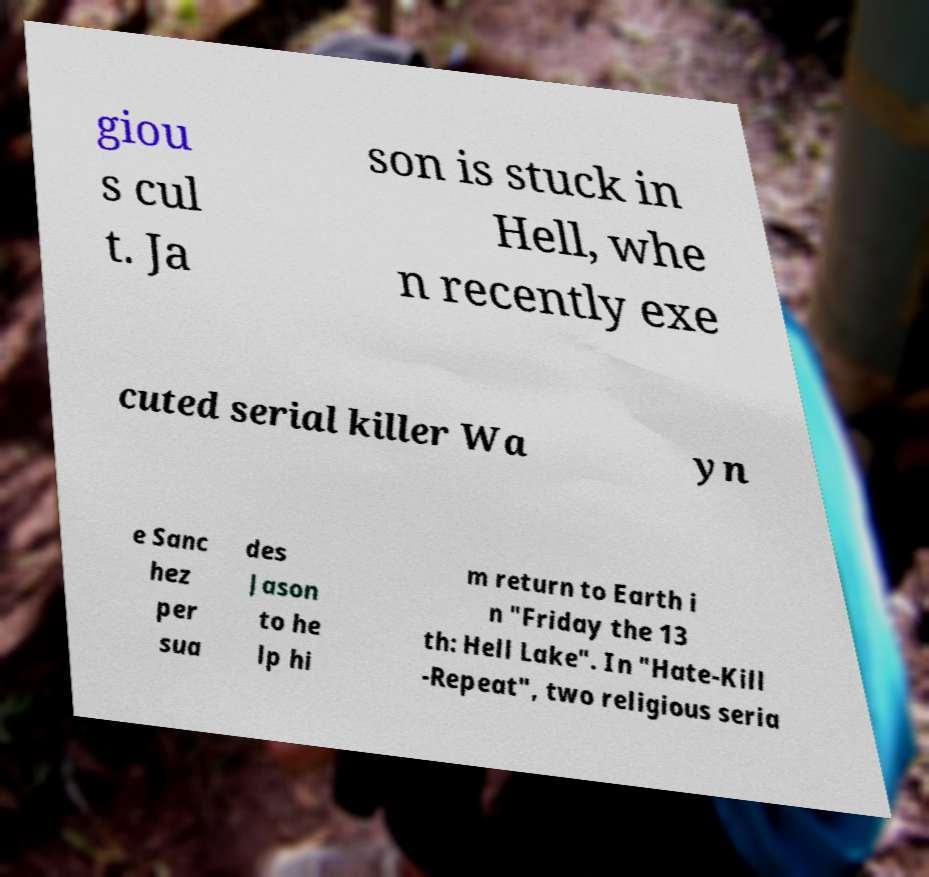Can you accurately transcribe the text from the provided image for me? giou s cul t. Ja son is stuck in Hell, whe n recently exe cuted serial killer Wa yn e Sanc hez per sua des Jason to he lp hi m return to Earth i n "Friday the 13 th: Hell Lake". In "Hate-Kill -Repeat", two religious seria 